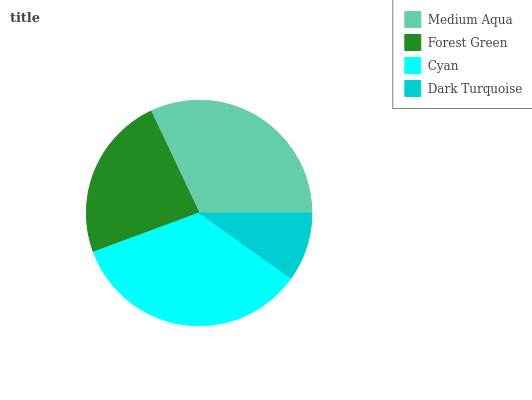Is Dark Turquoise the minimum?
Answer yes or no. Yes. Is Cyan the maximum?
Answer yes or no. Yes. Is Forest Green the minimum?
Answer yes or no. No. Is Forest Green the maximum?
Answer yes or no. No. Is Medium Aqua greater than Forest Green?
Answer yes or no. Yes. Is Forest Green less than Medium Aqua?
Answer yes or no. Yes. Is Forest Green greater than Medium Aqua?
Answer yes or no. No. Is Medium Aqua less than Forest Green?
Answer yes or no. No. Is Medium Aqua the high median?
Answer yes or no. Yes. Is Forest Green the low median?
Answer yes or no. Yes. Is Forest Green the high median?
Answer yes or no. No. Is Medium Aqua the low median?
Answer yes or no. No. 